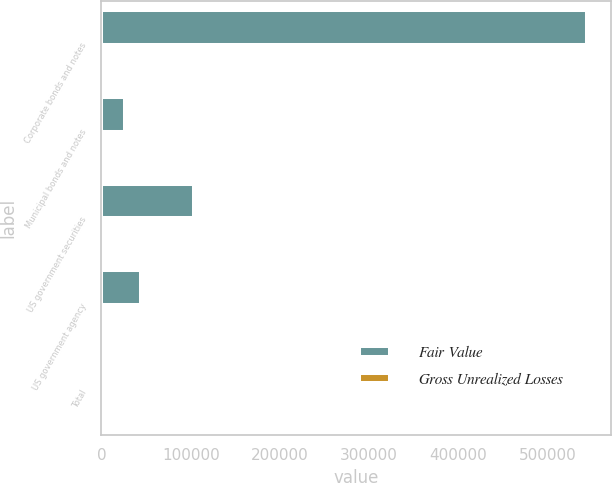Convert chart to OTSL. <chart><loc_0><loc_0><loc_500><loc_500><stacked_bar_chart><ecel><fcel>Corporate bonds and notes<fcel>Municipal bonds and notes<fcel>US government securities<fcel>US government agency<fcel>Total<nl><fcel>Fair Value<fcel>543729<fcel>26846<fcel>103470<fcel>44812<fcel>2314<nl><fcel>Gross Unrealized Losses<fcel>1800<fcel>123<fcel>281<fcel>110<fcel>2314<nl></chart> 